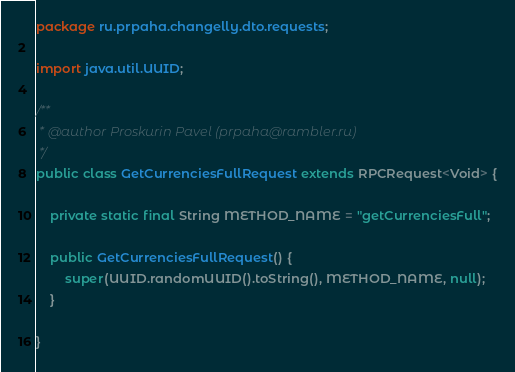Convert code to text. <code><loc_0><loc_0><loc_500><loc_500><_Java_>package ru.prpaha.changelly.dto.requests;

import java.util.UUID;

/**
 * @author Proskurin Pavel (prpaha@rambler.ru)
 */
public class GetCurrenciesFullRequest extends RPCRequest<Void> {

    private static final String METHOD_NAME = "getCurrenciesFull";

    public GetCurrenciesFullRequest() {
        super(UUID.randomUUID().toString(), METHOD_NAME, null);
    }

}
</code> 